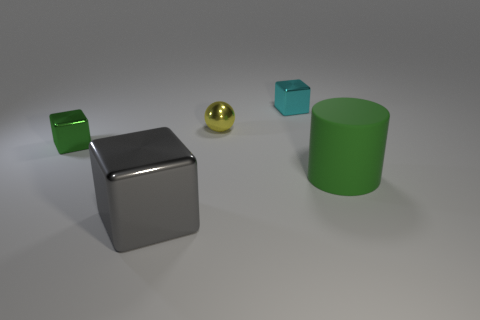Are there any other things that are made of the same material as the big green object?
Your answer should be very brief. No. The yellow sphere is what size?
Provide a succinct answer. Small. Are there an equal number of large objects left of the cyan shiny thing and small green things to the right of the big gray shiny object?
Keep it short and to the point. No. Are the small cube that is to the right of the small green cube and the object on the right side of the small cyan cube made of the same material?
Your answer should be compact. No. What number of other objects are the same size as the gray cube?
Offer a terse response. 1. How many objects are either matte cylinders or tiny metal things that are right of the yellow metal object?
Give a very brief answer. 2. Are there the same number of small cyan cubes in front of the big gray object and tiny yellow metal spheres?
Give a very brief answer. No. What shape is the gray thing that is the same material as the green cube?
Offer a terse response. Cube. Are there any metallic cubes that have the same color as the big rubber object?
Your answer should be very brief. Yes. How many rubber things are either large yellow things or small green things?
Your answer should be very brief. 0. 